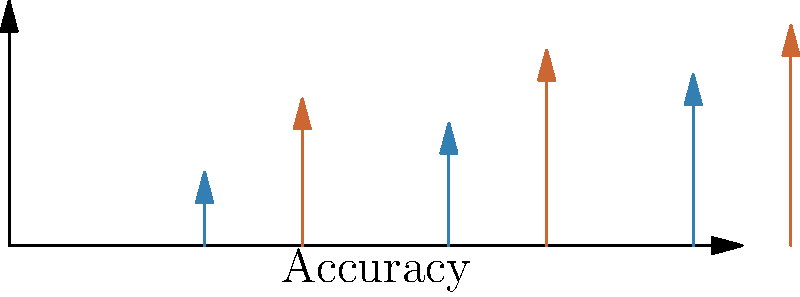The graph illustrates the impact of fact-checking initiatives on the accuracy rates of different types of information. If we calculate the average improvement across all three categories (social, political, and scientific), what is the percentage increase in accuracy? To solve this problem, we need to follow these steps:

1. Calculate the average accuracy rate before fact-checking:
   $\text{Average Before} = \frac{0.3 + 0.5 + 0.7}{3} = \frac{1.5}{3} = 0.5$ or 50%

2. Calculate the average accuracy rate after fact-checking:
   $\text{Average After} = \frac{0.6 + 0.8 + 0.9}{3} = \frac{2.3}{3} \approx 0.7667$ or 76.67%

3. Calculate the difference between the two averages:
   $\text{Difference} = 0.7667 - 0.5 = 0.2667$ or 26.67 percentage points

4. Calculate the percentage increase:
   $\text{Percentage Increase} = \frac{\text{Difference}}{\text{Original Value}} \times 100\%$
   $= \frac{0.2667}{0.5} \times 100\% = 0.5333 \times 100\% = 53.33\%$

Therefore, the average improvement across all three categories is approximately 53.33%.
Answer: 53.33% 